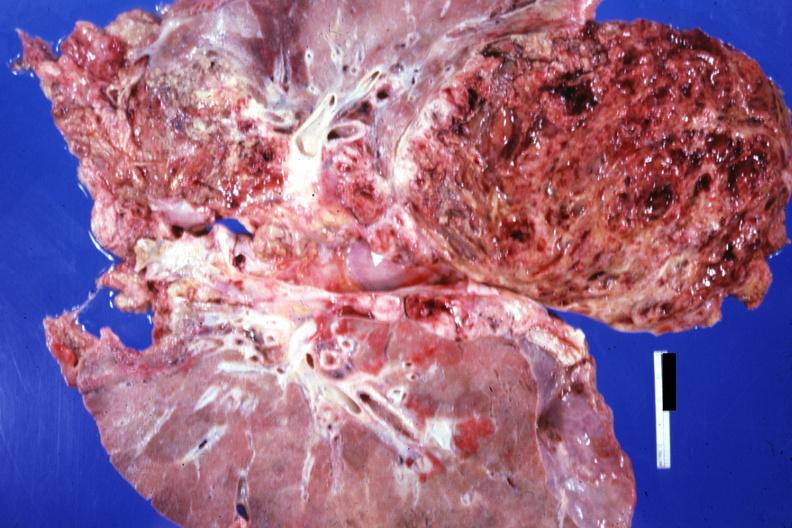where is this?
Answer the question using a single word or phrase. Thorax 